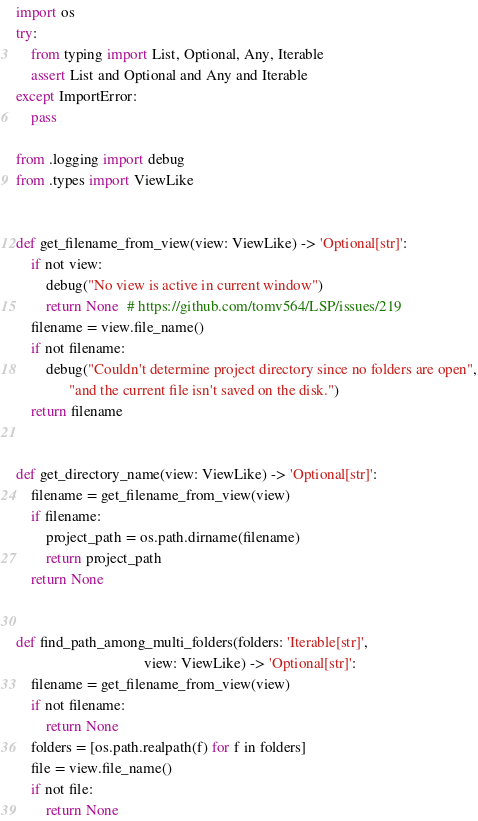<code> <loc_0><loc_0><loc_500><loc_500><_Python_>import os
try:
    from typing import List, Optional, Any, Iterable
    assert List and Optional and Any and Iterable
except ImportError:
    pass

from .logging import debug
from .types import ViewLike


def get_filename_from_view(view: ViewLike) -> 'Optional[str]':
    if not view:
        debug("No view is active in current window")
        return None  # https://github.com/tomv564/LSP/issues/219
    filename = view.file_name()
    if not filename:
        debug("Couldn't determine project directory since no folders are open",
              "and the current file isn't saved on the disk.")
    return filename


def get_directory_name(view: ViewLike) -> 'Optional[str]':
    filename = get_filename_from_view(view)
    if filename:
        project_path = os.path.dirname(filename)
        return project_path
    return None


def find_path_among_multi_folders(folders: 'Iterable[str]',
                                  view: ViewLike) -> 'Optional[str]':
    filename = get_filename_from_view(view)
    if not filename:
        return None
    folders = [os.path.realpath(f) for f in folders]
    file = view.file_name()
    if not file:
        return None</code> 